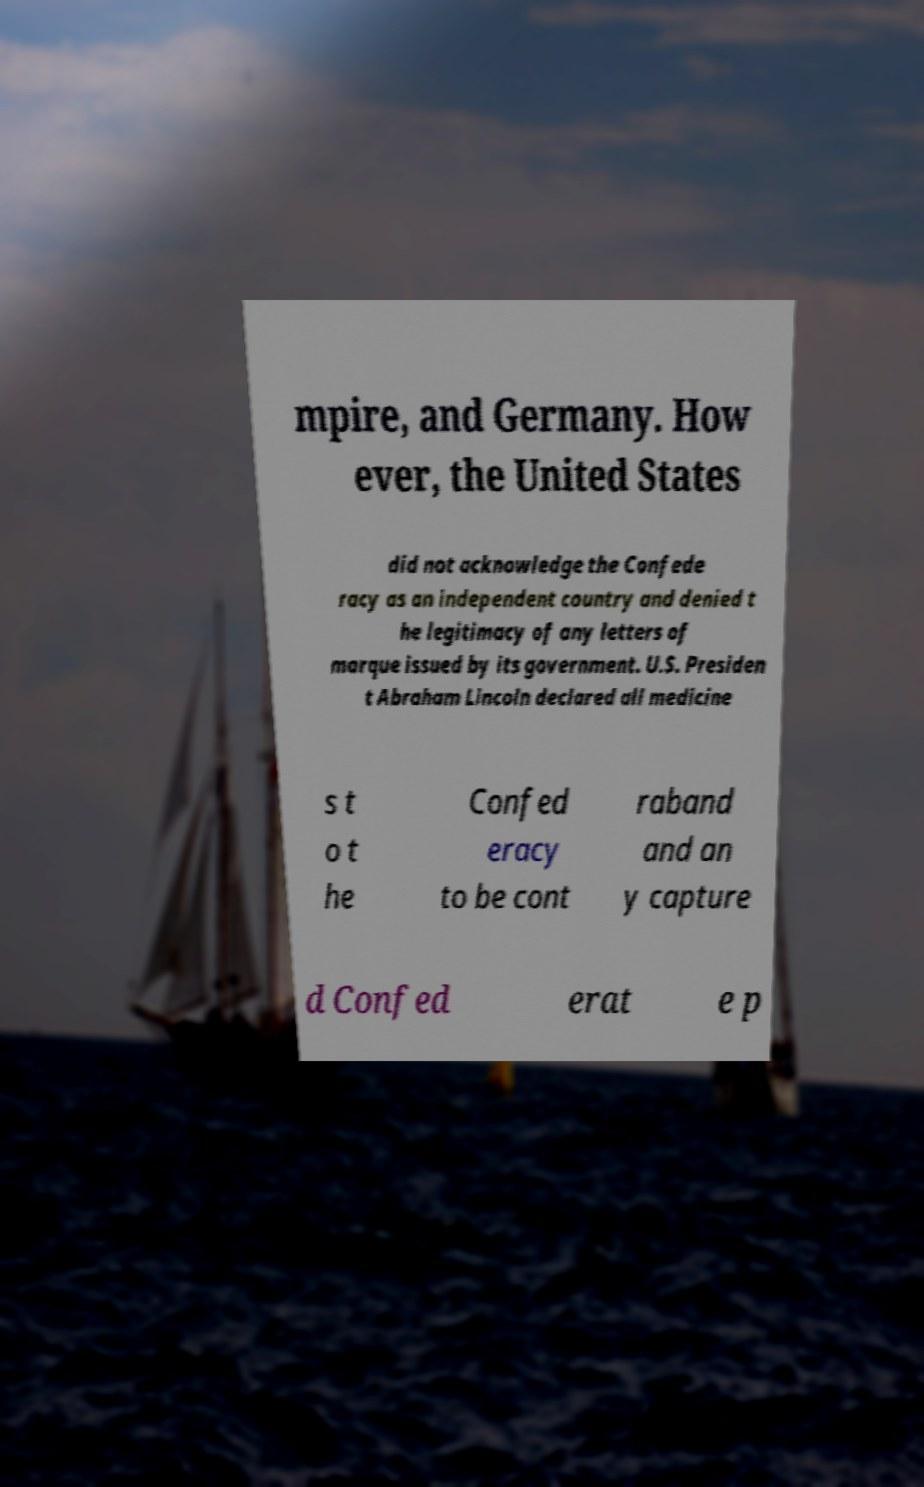There's text embedded in this image that I need extracted. Can you transcribe it verbatim? mpire, and Germany. How ever, the United States did not acknowledge the Confede racy as an independent country and denied t he legitimacy of any letters of marque issued by its government. U.S. Presiden t Abraham Lincoln declared all medicine s t o t he Confed eracy to be cont raband and an y capture d Confed erat e p 